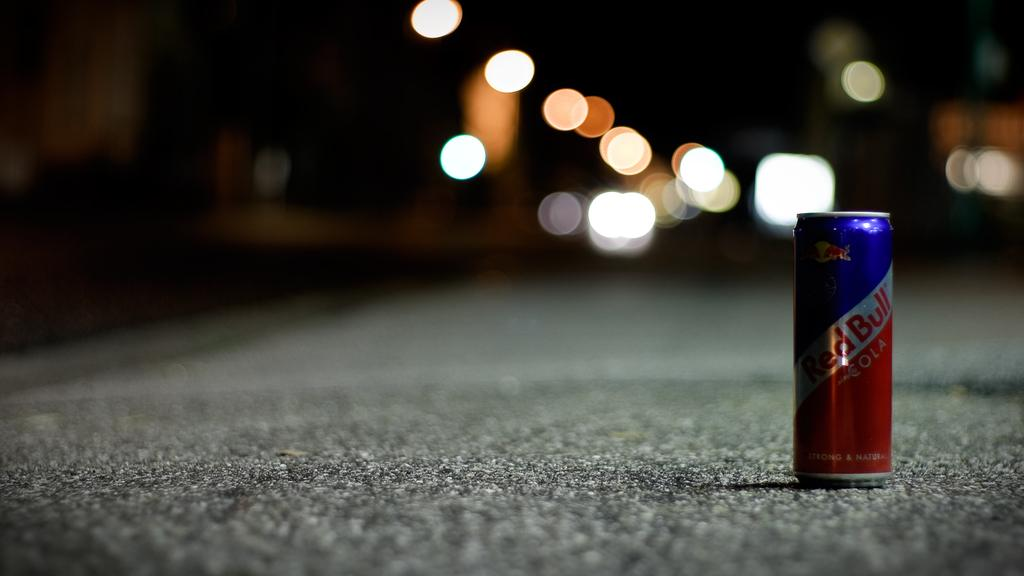<image>
Offer a succinct explanation of the picture presented. A can of Red Bull is sitting in the middle of a street with blurred lights in the background. 